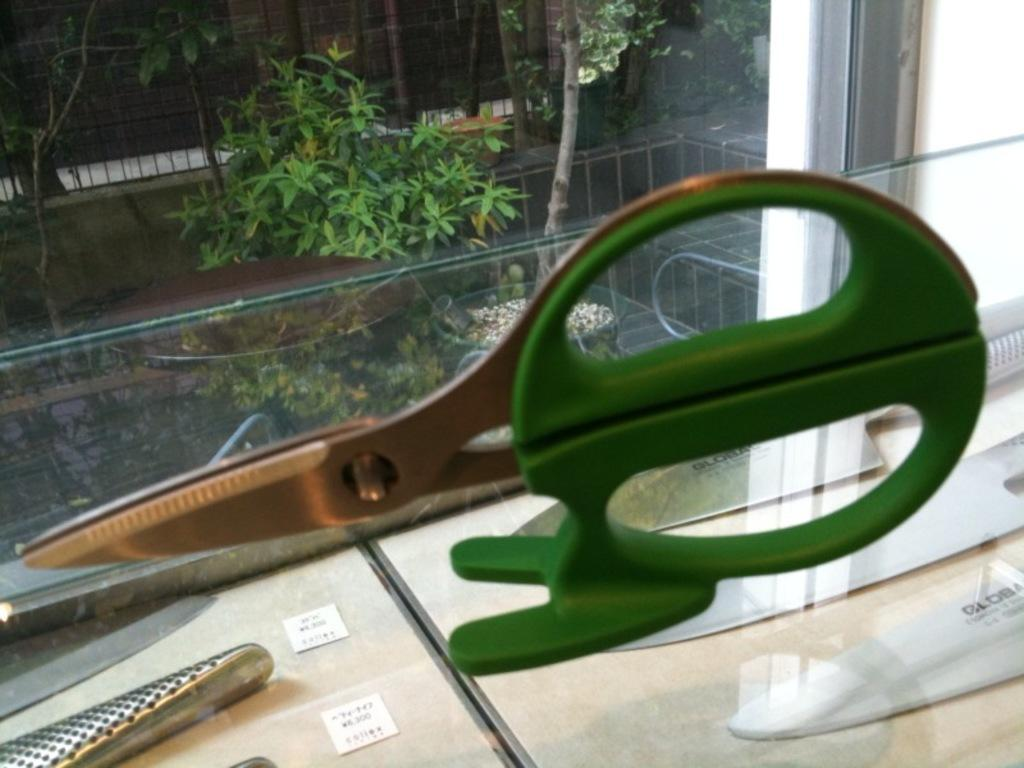What is placed on the glass in the image? There are scissors on the glass in the image. What objects are on the boards in the image? There are knives and cards on the boards in the image. What can be seen in the background of the image? There are trees in the background of the image. What type of honey is being used to write on the cards in the image? There is no honey present in the image, and no writing on the cards is mentioned. 